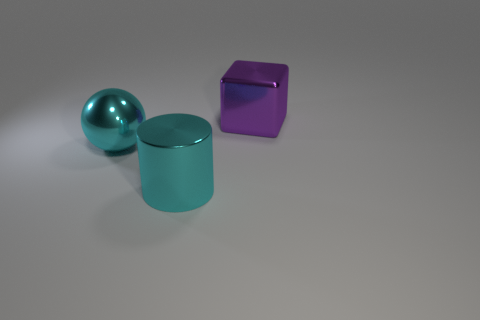Add 3 large purple rubber blocks. How many objects exist? 6 Subtract all cubes. How many objects are left? 2 Subtract 1 cylinders. How many cylinders are left? 0 Subtract all gray spheres. Subtract all brown blocks. How many spheres are left? 1 Subtract all big spheres. Subtract all large brown rubber cubes. How many objects are left? 2 Add 3 large cyan metallic cylinders. How many large cyan metallic cylinders are left? 4 Add 3 large shiny cubes. How many large shiny cubes exist? 4 Subtract 1 purple cubes. How many objects are left? 2 